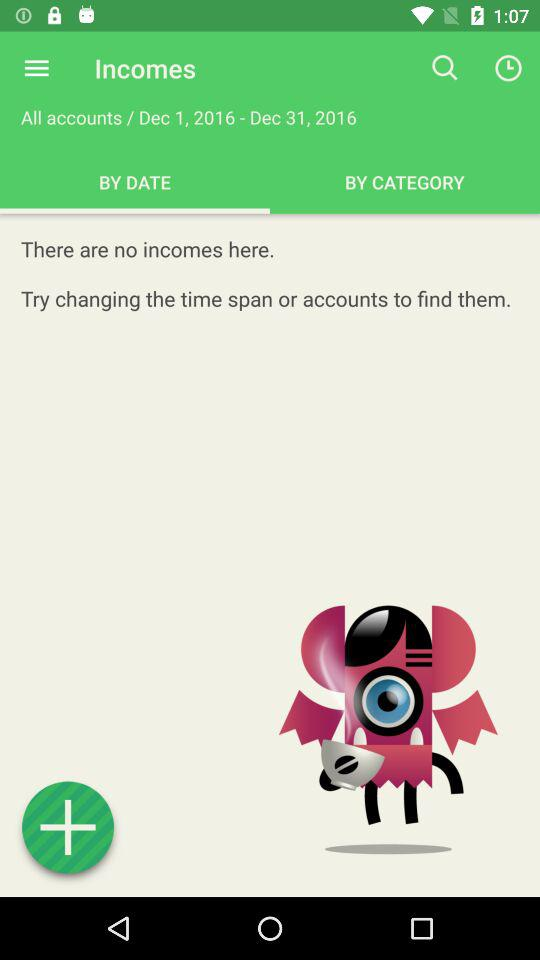Which tab is selected? The selected tab is "BY DATE". 